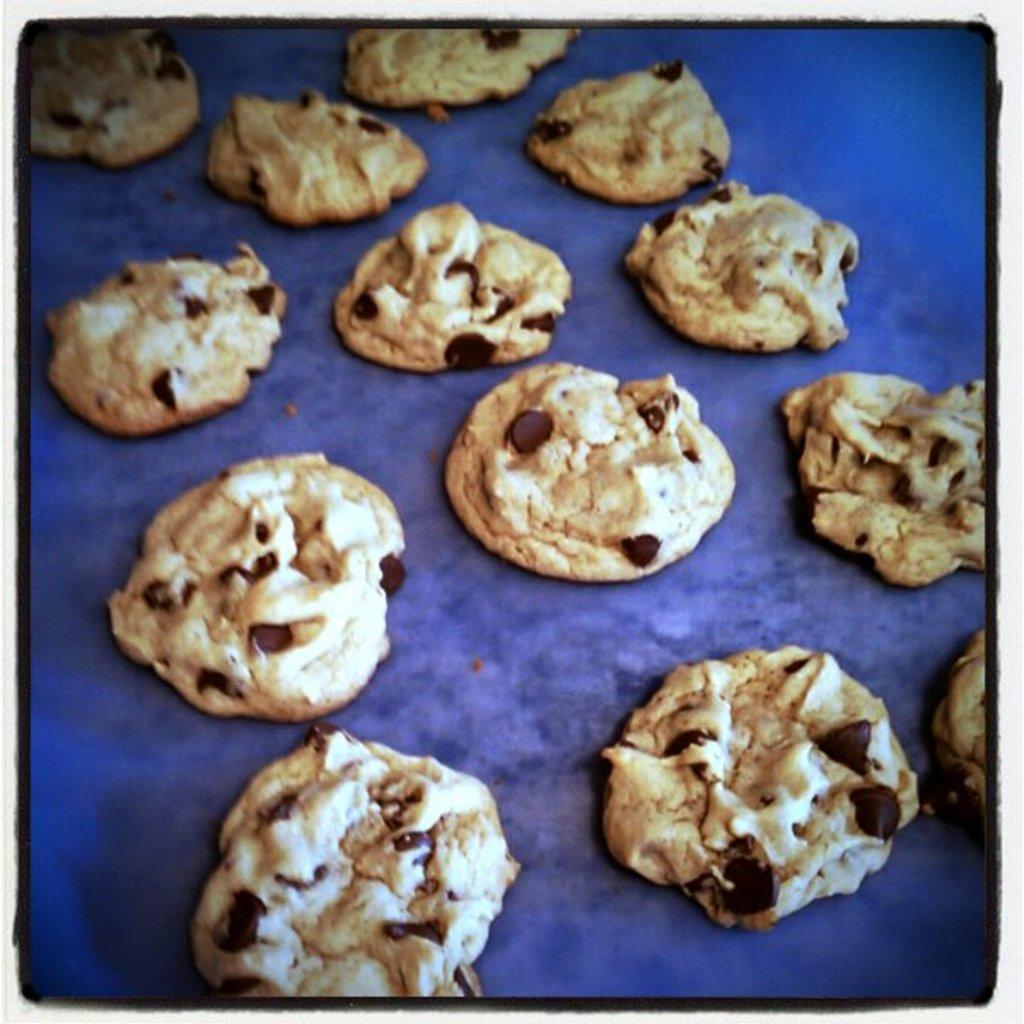Describe this image in one or two sentences. It is an edited image and in the picture there are some cookies kept on a blue color surface. 